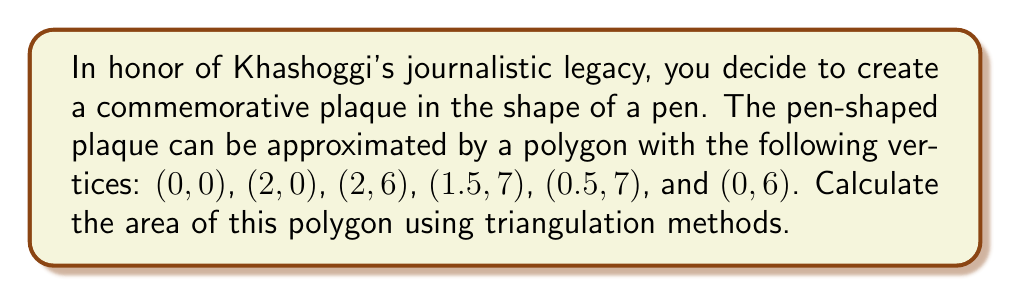Can you answer this question? Let's approach this step-by-step using triangulation:

1) First, we'll divide the polygon into four triangles:
   T1: (0,0), (2,0), (2,6)
   T2: (0,0), (2,6), (0,6)
   T3: (0,6), (2,6), (1.5,7)
   T4: (0,6), (1.5,7), (0.5,7)

2) Now, let's calculate the area of each triangle using the formula:
   $$ A = \frac{1}{2}|x_1(y_2 - y_3) + x_2(y_3 - y_1) + x_3(y_1 - y_2)| $$

3) For T1:
   $$ A_1 = \frac{1}{2}|0(0 - 6) + 2(6 - 0) + 2(0 - 0)| = 6 $$

4) For T2:
   $$ A_2 = \frac{1}{2}|0(6 - 6) + 2(6 - 0) + 0(0 - 6)| = 6 $$

5) For T3:
   $$ A_3 = \frac{1}{2}|0(6 - 7) + 2(7 - 6) + 1.5(6 - 6)| = 0.5 $$

6) For T4:
   $$ A_4 = \frac{1}{2}|0(7 - 7) + 1.5(7 - 6) + 0.5(6 - 7)| = 0.25 $$

7) The total area is the sum of these four triangles:
   $$ A_{total} = A_1 + A_2 + A_3 + A_4 = 6 + 6 + 0.5 + 0.25 = 12.75 $$

Therefore, the area of the pen-shaped plaque is 12.75 square units.
Answer: 12.75 square units 